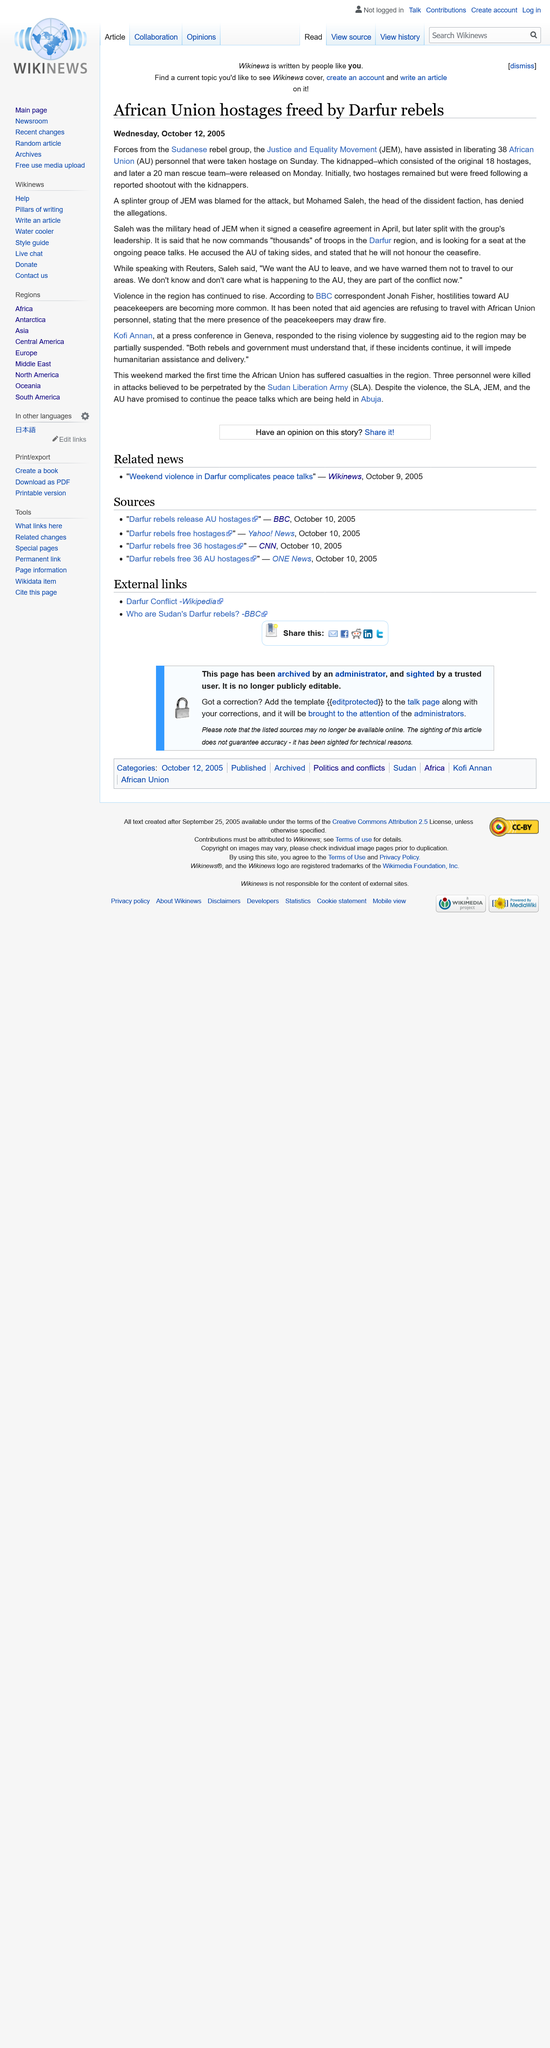Identify some key points in this picture. Mohamed Saleh was the military head of the Justice and Equality Movement (JEM) when it signed a ceasefire agreement with the Sudanese government in April. On Wednesday, October 12, 2005, the article regarding the freeing of African Union hostages by Darfur rebels was published. Justice and Equality Movement, commonly known as JEM, is a political movement dedicated to promoting justice and equality in our society. 